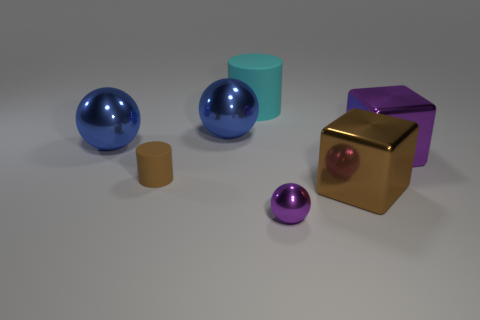Add 3 purple shiny things. How many objects exist? 10 Subtract all cylinders. How many objects are left? 5 Add 5 small brown matte things. How many small brown matte things exist? 6 Subtract 0 cyan balls. How many objects are left? 7 Subtract all brown cubes. Subtract all cyan rubber cylinders. How many objects are left? 5 Add 1 small purple objects. How many small purple objects are left? 2 